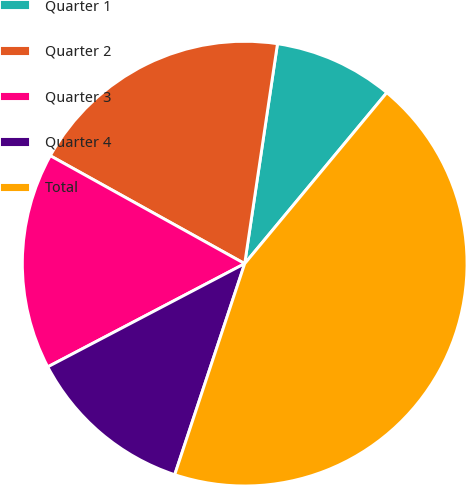<chart> <loc_0><loc_0><loc_500><loc_500><pie_chart><fcel>Quarter 1<fcel>Quarter 2<fcel>Quarter 3<fcel>Quarter 4<fcel>Total<nl><fcel>8.68%<fcel>19.29%<fcel>15.75%<fcel>12.22%<fcel>44.06%<nl></chart> 